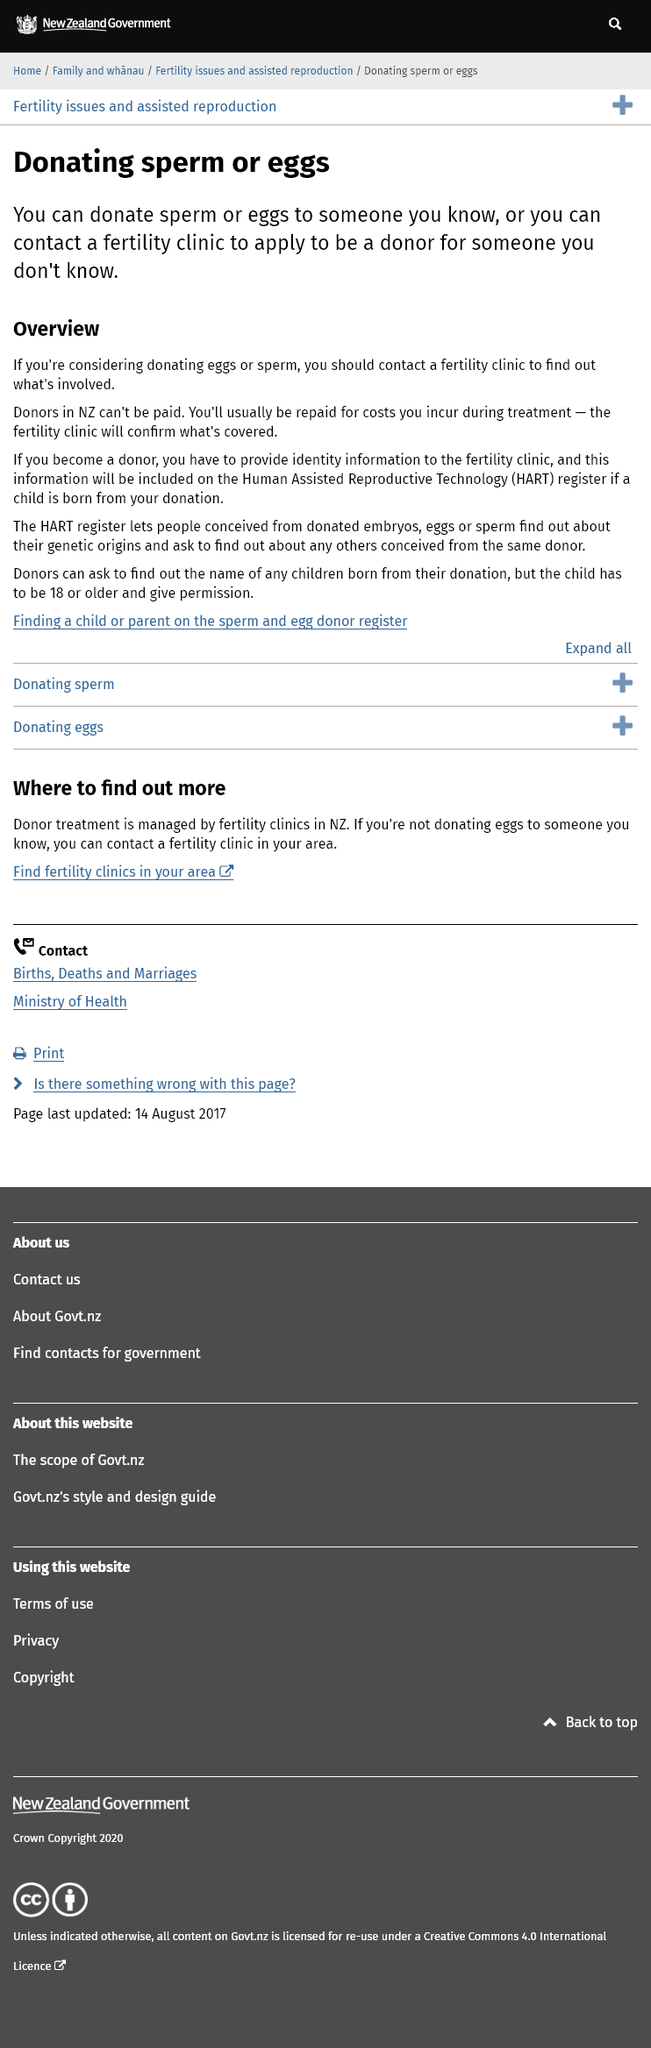Draw attention to some important aspects in this diagram. Human Assisted Reproductive Technology (HART) is a term that refers to various techniques used to assist human reproduction, such as in vitro fertilization and surrogacy. Donors in New Zealand are not legally allowed to receive payment for their contributions. It is necessary to contact a fertility clinic in order to apply to be a sperm or egg donor for someone whom you do not know. 